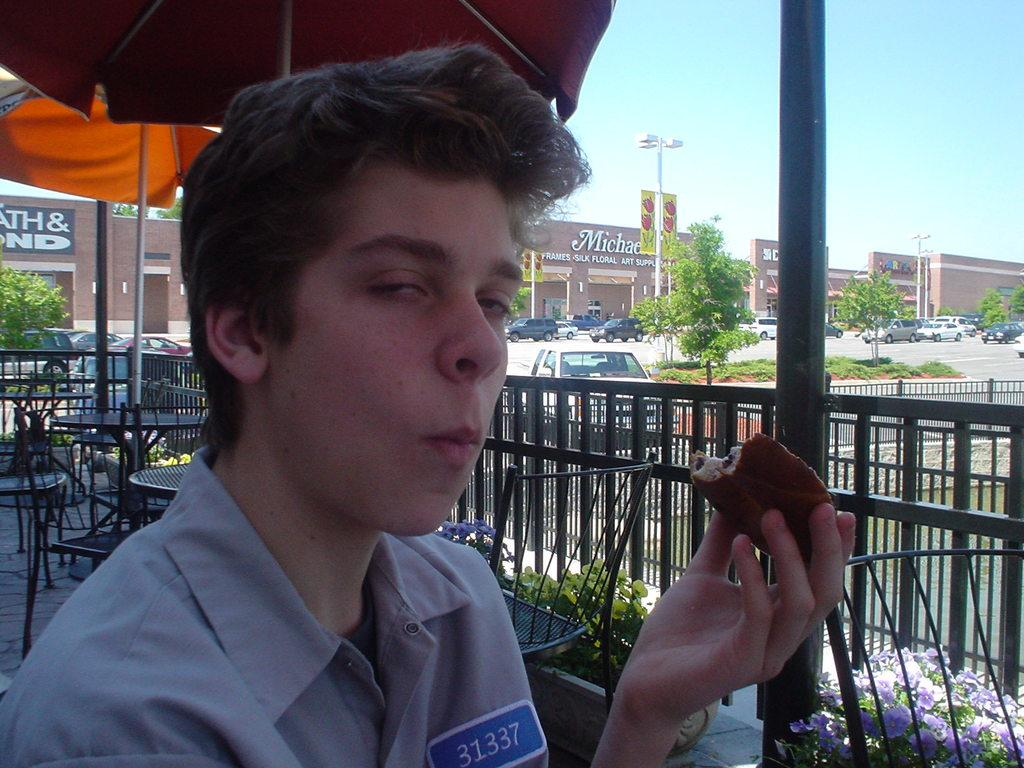Provide a one-sentence caption for the provided image. Person eating something while wearing a tag that says 31337. 